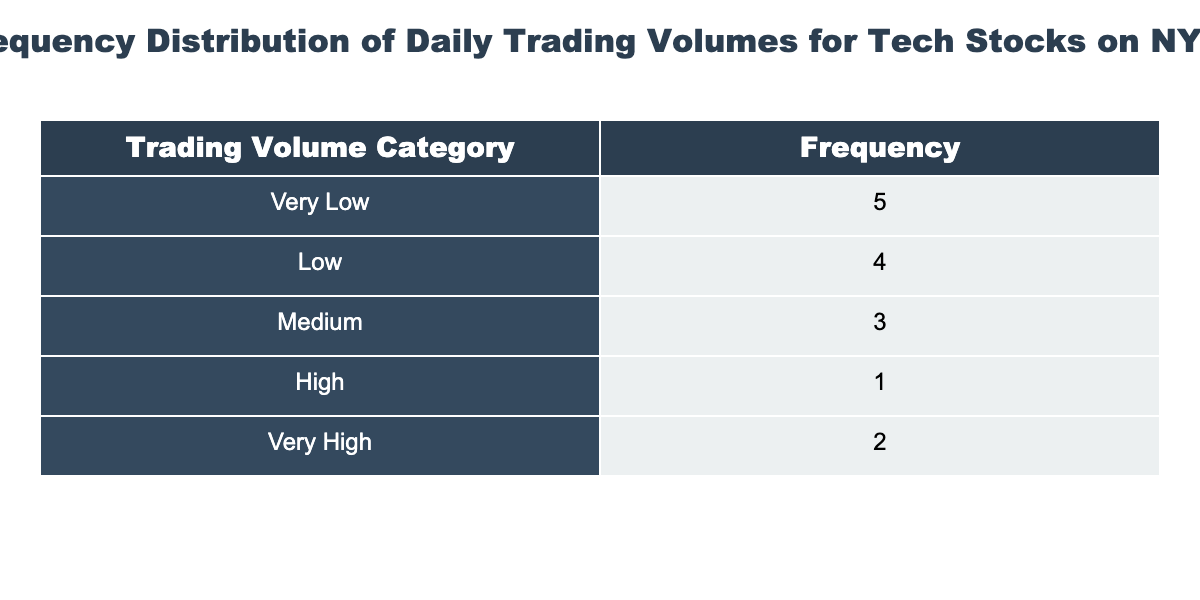What is the frequency of the 'Very High' trading volume category? From the table, we can see that the 'Very High' category corresponds to trading volumes above 80,000,000. By checking the counts for each category, we can see that there are no stocks in this category.
Answer: 0 Which trading volume category has the highest frequency? We can look at the frequencies listed in the table. Upon comparison, the 'High' category appears more frequently than the others.
Answer: High How many stocks fall into the 'Low' trading volume category? According to the table, the 'Low' category consists of stocks with trading volumes between 10,000,000 and 30,000,000. By counting the stocks that fit this criterion, we find that there are 5 stocks in this category.
Answer: 5 What is the total trading volume for stocks in the 'Medium' category? First, we identify which stocks fall into the 'Medium' category, then sum their daily trading volumes: 39,000,000 (NVIDIA) + 47,000,000 (Tesla) + 43,000,000 (PayPal) + 30,000,000 (Twitter) = 159,000,000.
Answer: 159000000 Is there any stock with a trading volume below 10,000,000? By examining the trading volumes listed in the table, we note that the lowest value is 6,000,000 (Snap Inc.), indicating that at least one stock does fall below this threshold.
Answer: Yes What is the average trading volume for stocks categorized as 'High'? The 'High' category includes trading volumes: 39,000,000 (NVIDIA) + 47,000,000 (Tesla) + 43,000,000 (PayPal) + 30,000,000 (Twitter) = 159,000,000. Divided by the 4 stocks in this category gives us an average of 39,750,000.
Answer: 39750000 How many stocks have trading volumes greater than 60,000,000? By reviewing the trading volumes, we see that the only stocks that exceed 60,000,000 are Apple Inc. and Microsoft Corp., accounting for 2 stocks in total.
Answer: 2 What is the lowest trading volume recorded in the data? By scanning the recorded trading volumes, we determine that the lowest value present is for Snap Inc., which is 6,000,000.
Answer: 6000000 How many stocks are there in total in the dataset? By counting the individual stocks mentioned in the table, we find there are 14 stocks listed.
Answer: 14 